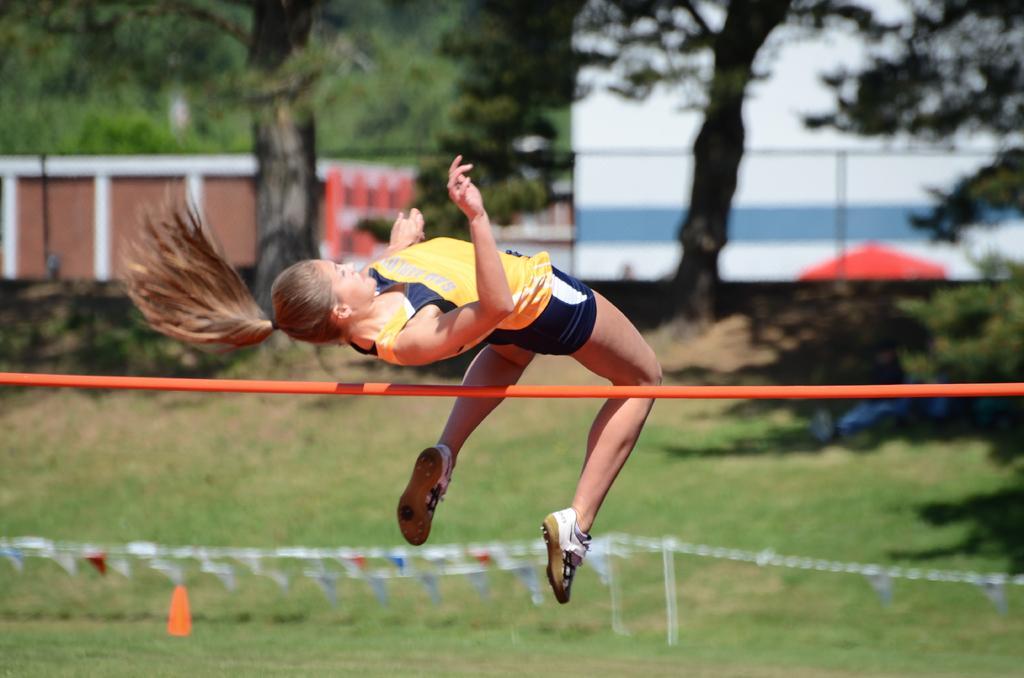Could you give a brief overview of what you see in this image? Here in this picture we can see a woman performing high jump and we can see a pole behind her and we can see the ground is fully covered with grass over there and we can see trees and plants here and there. 